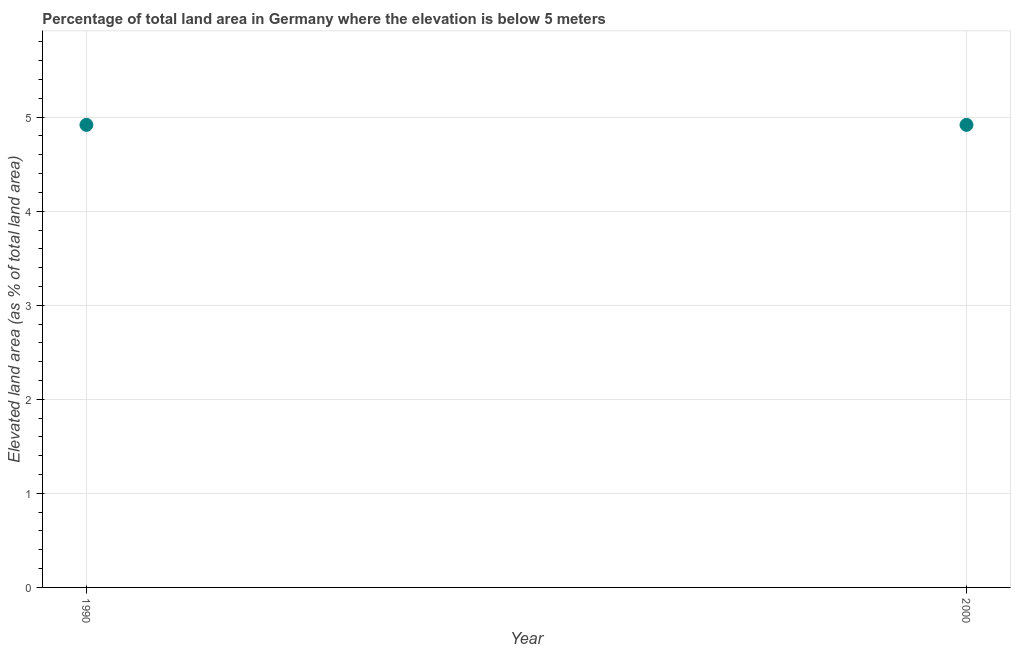What is the total elevated land area in 2000?
Your answer should be compact. 4.92. Across all years, what is the maximum total elevated land area?
Offer a terse response. 4.92. Across all years, what is the minimum total elevated land area?
Your answer should be compact. 4.92. In which year was the total elevated land area minimum?
Your answer should be very brief. 1990. What is the sum of the total elevated land area?
Provide a succinct answer. 9.84. What is the difference between the total elevated land area in 1990 and 2000?
Make the answer very short. 0. What is the average total elevated land area per year?
Provide a short and direct response. 4.92. What is the median total elevated land area?
Keep it short and to the point. 4.92. Do a majority of the years between 2000 and 1990 (inclusive) have total elevated land area greater than 1.6 %?
Provide a short and direct response. No. What is the ratio of the total elevated land area in 1990 to that in 2000?
Your response must be concise. 1. How many dotlines are there?
Your answer should be compact. 1. Are the values on the major ticks of Y-axis written in scientific E-notation?
Ensure brevity in your answer.  No. What is the title of the graph?
Provide a short and direct response. Percentage of total land area in Germany where the elevation is below 5 meters. What is the label or title of the X-axis?
Your answer should be very brief. Year. What is the label or title of the Y-axis?
Your answer should be very brief. Elevated land area (as % of total land area). What is the Elevated land area (as % of total land area) in 1990?
Keep it short and to the point. 4.92. What is the Elevated land area (as % of total land area) in 2000?
Offer a very short reply. 4.92. What is the difference between the Elevated land area (as % of total land area) in 1990 and 2000?
Make the answer very short. 0. 